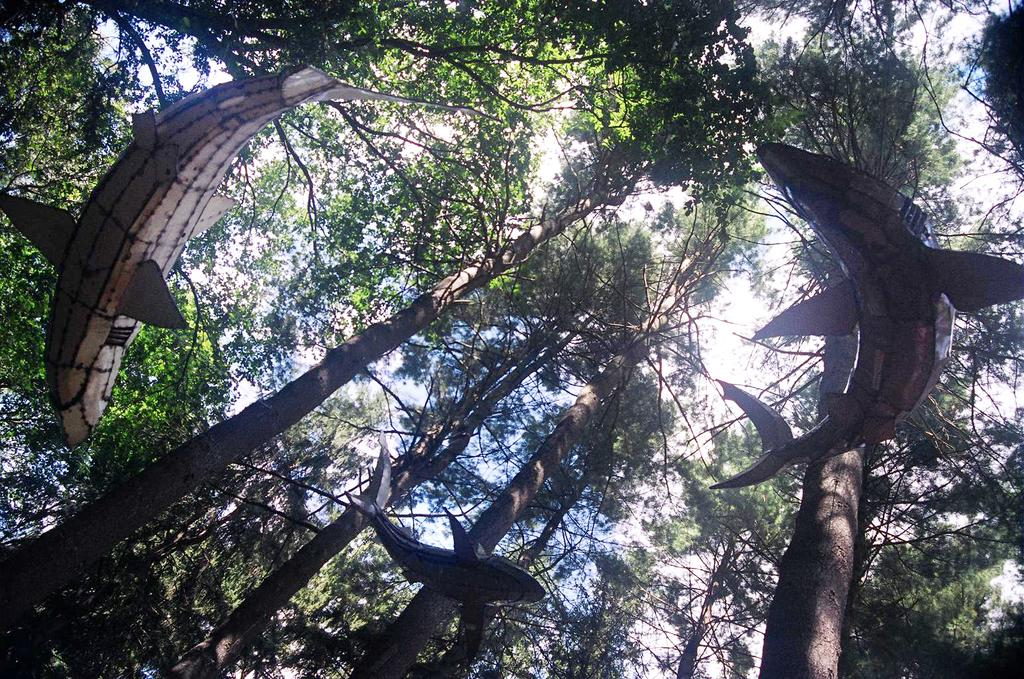What type of animals can be seen in the image? There are fishes depicted in the image. What can be seen in the background of the image? There are trees visible in the background of the image. What type of camera can be seen in the image? There is no camera present in the image; it features fishes and trees in the background. How many giants are visible in the image? There are no giants depicted in the image; it features fishes and trees in the background. 